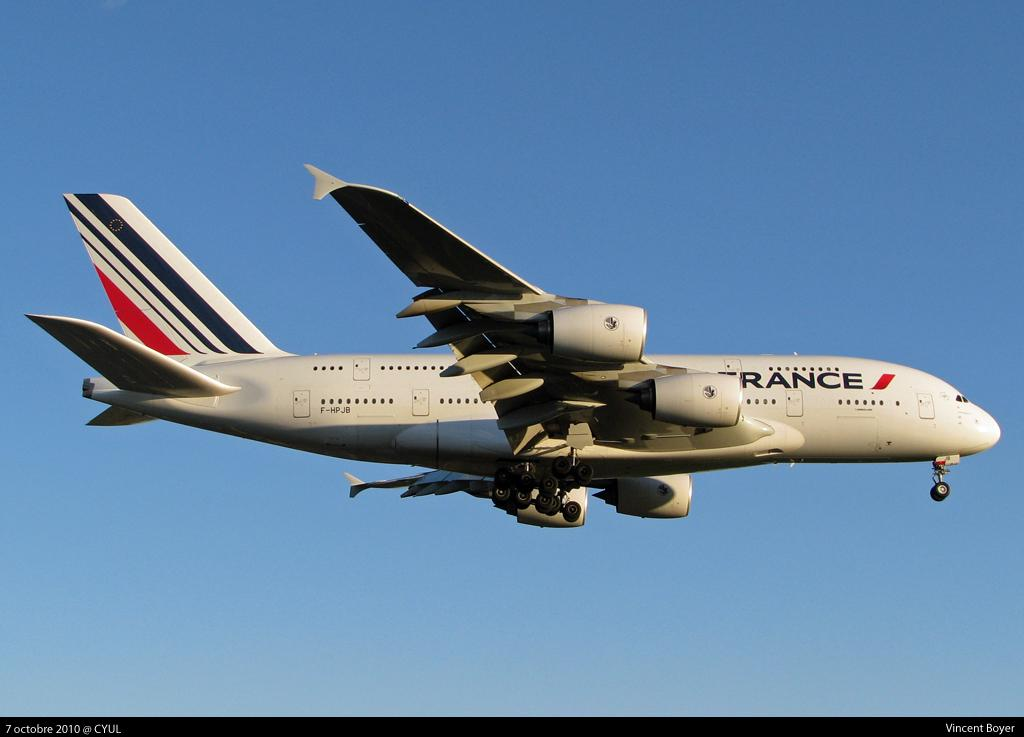<image>
Offer a succinct explanation of the picture presented. An Air France airplane is flying in the sky. 